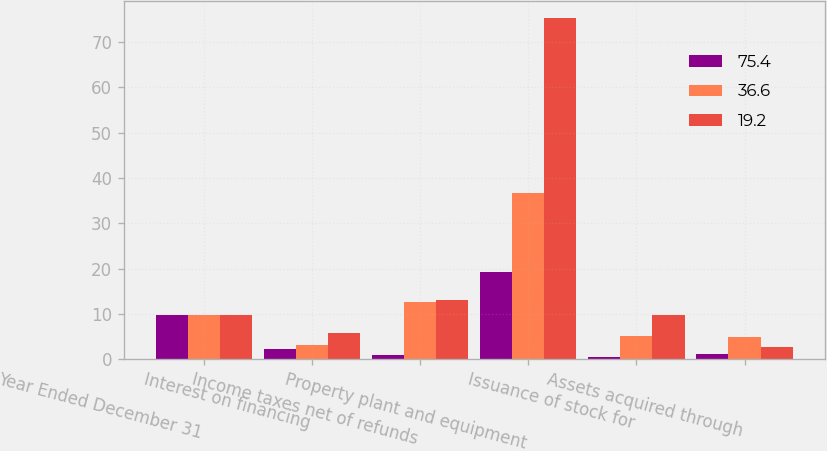Convert chart. <chart><loc_0><loc_0><loc_500><loc_500><stacked_bar_chart><ecel><fcel>Year Ended December 31<fcel>Interest on financing<fcel>Income taxes net of refunds<fcel>Property plant and equipment<fcel>Issuance of stock for<fcel>Assets acquired through<nl><fcel>75.4<fcel>9.7<fcel>2.3<fcel>0.9<fcel>19.2<fcel>0.5<fcel>1.2<nl><fcel>36.6<fcel>9.7<fcel>3.1<fcel>12.7<fcel>36.6<fcel>5.1<fcel>4.8<nl><fcel>19.2<fcel>9.7<fcel>5.8<fcel>13.1<fcel>75.4<fcel>9.7<fcel>2.7<nl></chart> 